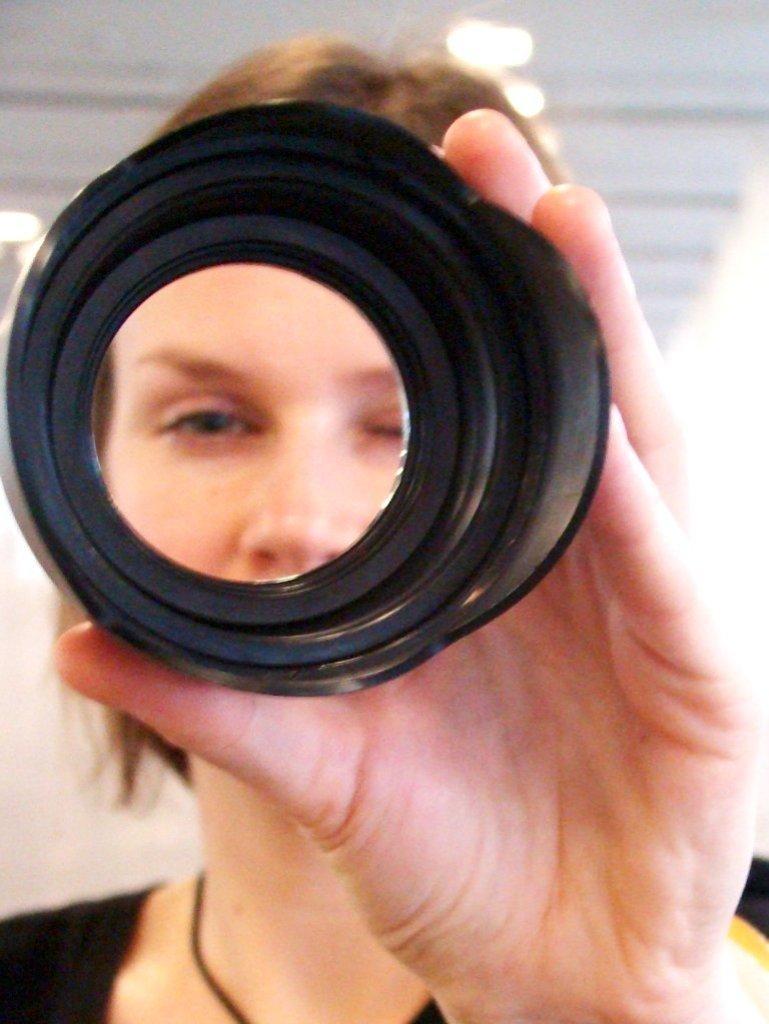Please provide a concise description of this image. In this image we can see a lady holding a black color object. In the background it is blur. 